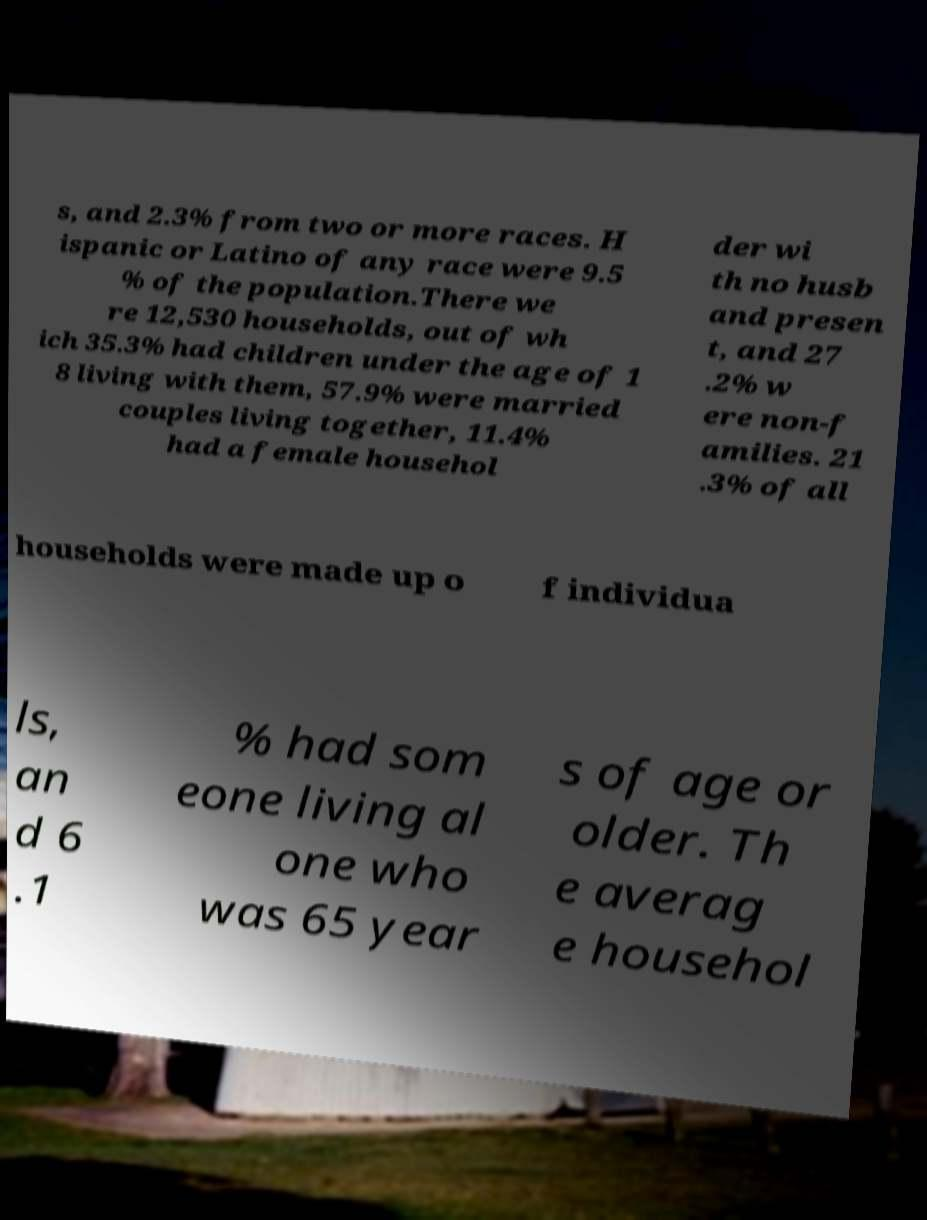Could you extract and type out the text from this image? s, and 2.3% from two or more races. H ispanic or Latino of any race were 9.5 % of the population.There we re 12,530 households, out of wh ich 35.3% had children under the age of 1 8 living with them, 57.9% were married couples living together, 11.4% had a female househol der wi th no husb and presen t, and 27 .2% w ere non-f amilies. 21 .3% of all households were made up o f individua ls, an d 6 .1 % had som eone living al one who was 65 year s of age or older. Th e averag e househol 